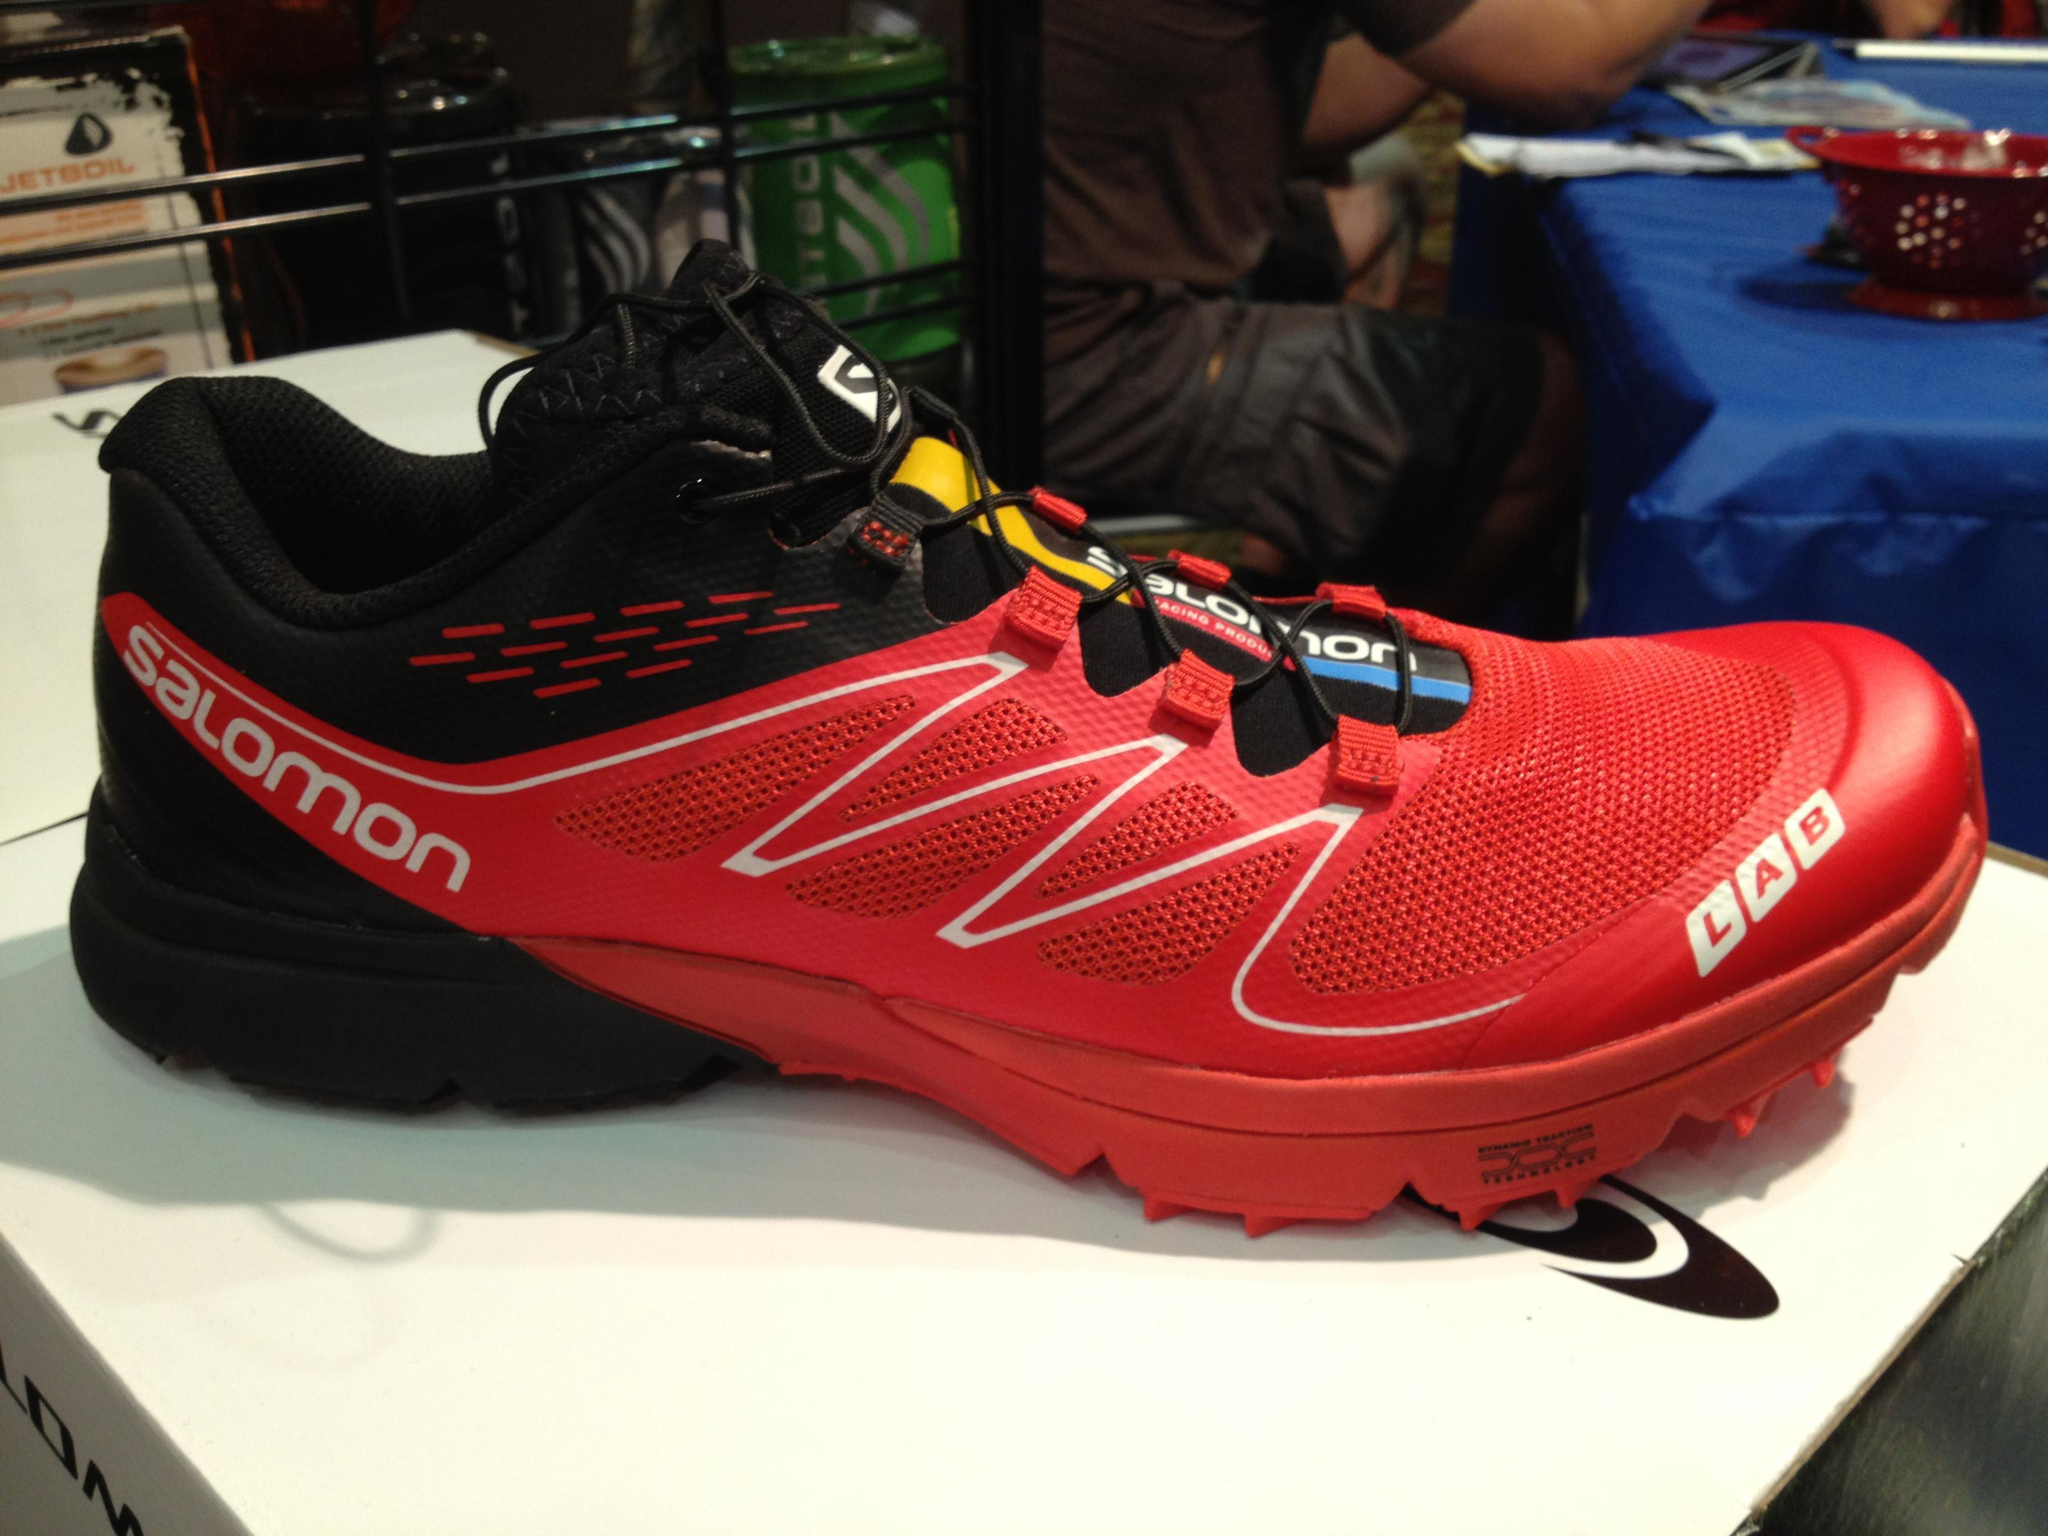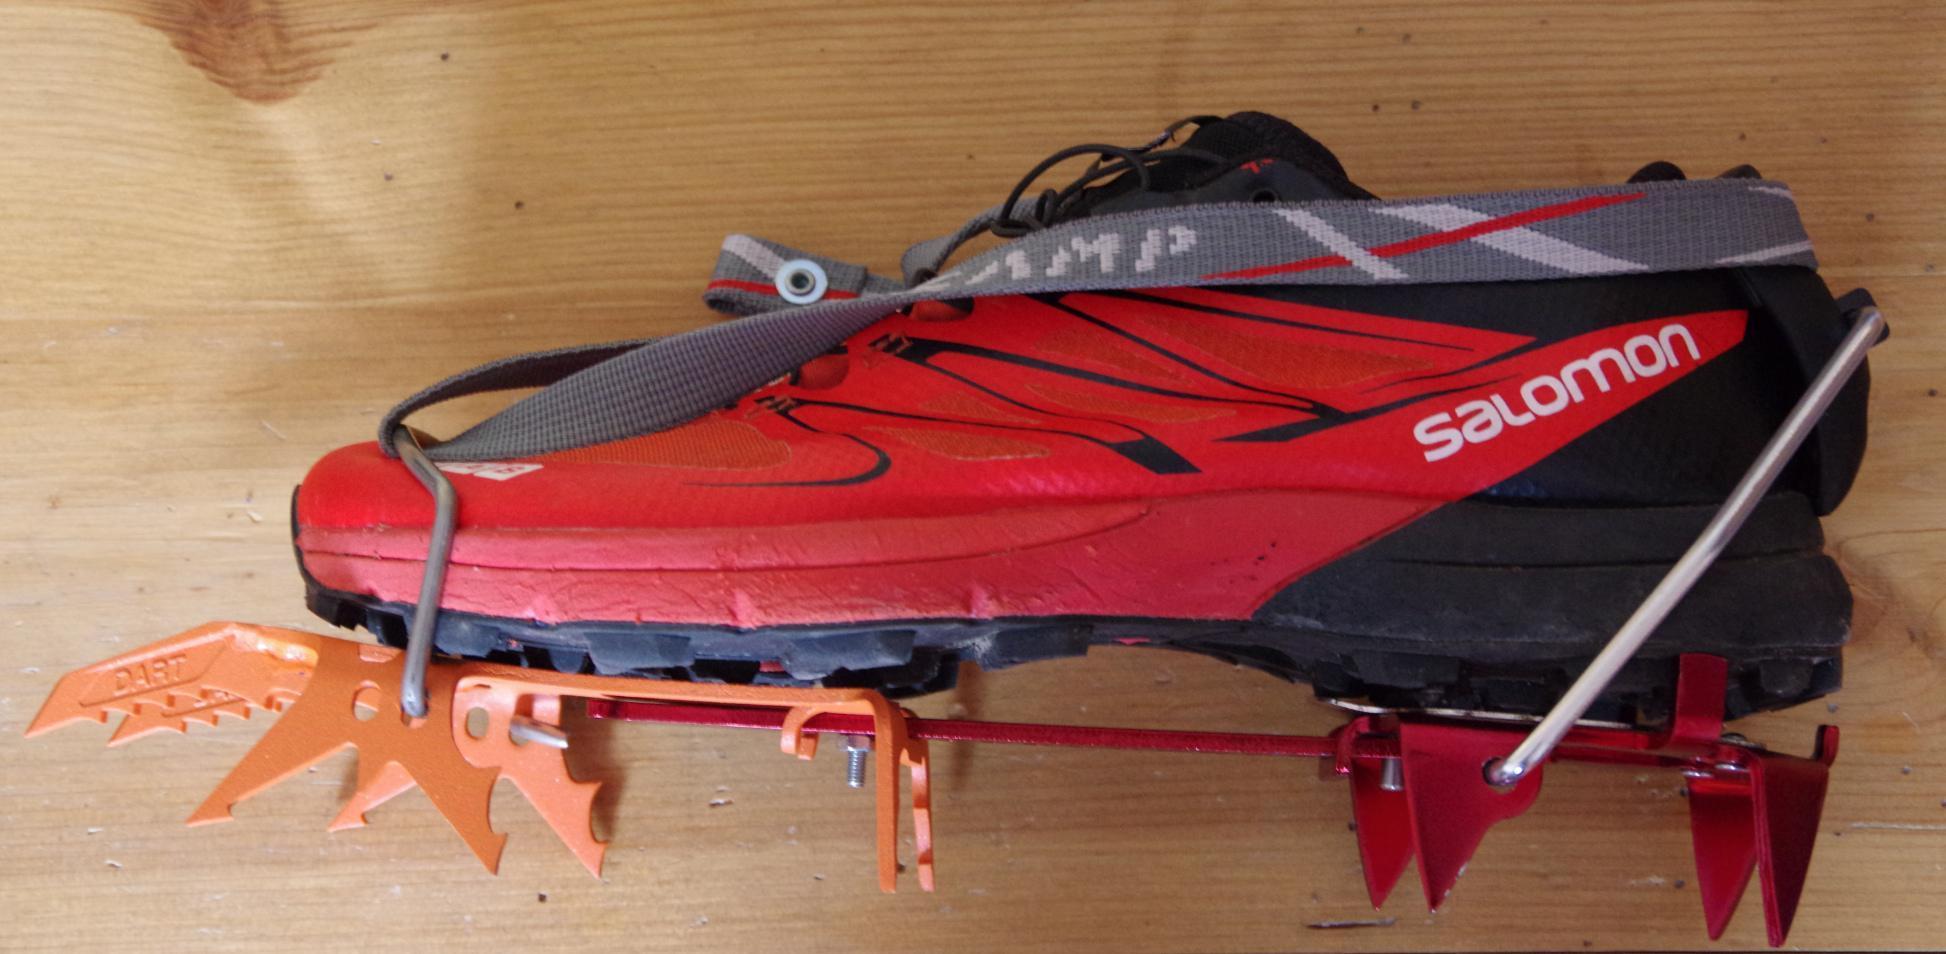The first image is the image on the left, the second image is the image on the right. For the images shown, is this caption "All of the shoes in the images are being displayed indoors." true? Answer yes or no. Yes. The first image is the image on the left, the second image is the image on the right. Assess this claim about the two images: "Each image contains one sneaker that includes red color, and the shoes in the left and right images face different directions.". Correct or not? Answer yes or no. Yes. 